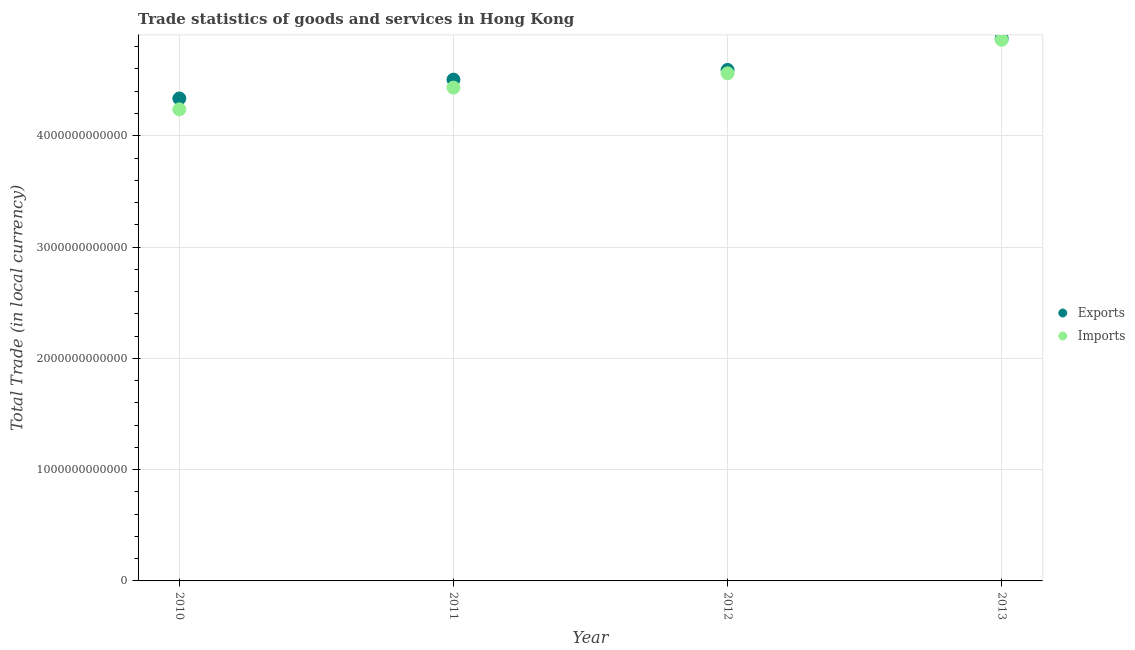Is the number of dotlines equal to the number of legend labels?
Ensure brevity in your answer.  Yes. What is the imports of goods and services in 2010?
Provide a succinct answer. 4.24e+12. Across all years, what is the maximum export of goods and services?
Your answer should be compact. 4.87e+12. Across all years, what is the minimum export of goods and services?
Make the answer very short. 4.34e+12. In which year was the imports of goods and services minimum?
Provide a succinct answer. 2010. What is the total export of goods and services in the graph?
Your response must be concise. 1.83e+13. What is the difference between the export of goods and services in 2012 and that in 2013?
Provide a succinct answer. -2.83e+11. What is the difference between the imports of goods and services in 2011 and the export of goods and services in 2010?
Ensure brevity in your answer.  9.74e+1. What is the average export of goods and services per year?
Your answer should be compact. 4.58e+12. In the year 2010, what is the difference between the export of goods and services and imports of goods and services?
Give a very brief answer. 9.79e+1. What is the ratio of the imports of goods and services in 2011 to that in 2012?
Offer a terse response. 0.97. Is the export of goods and services in 2012 less than that in 2013?
Keep it short and to the point. Yes. What is the difference between the highest and the second highest imports of goods and services?
Make the answer very short. 3.01e+11. What is the difference between the highest and the lowest export of goods and services?
Give a very brief answer. 5.40e+11. In how many years, is the imports of goods and services greater than the average imports of goods and services taken over all years?
Ensure brevity in your answer.  2. Is the sum of the imports of goods and services in 2011 and 2012 greater than the maximum export of goods and services across all years?
Ensure brevity in your answer.  Yes. Does the export of goods and services monotonically increase over the years?
Your response must be concise. Yes. Is the export of goods and services strictly greater than the imports of goods and services over the years?
Ensure brevity in your answer.  Yes. Is the imports of goods and services strictly less than the export of goods and services over the years?
Offer a very short reply. Yes. What is the difference between two consecutive major ticks on the Y-axis?
Give a very brief answer. 1.00e+12. Does the graph contain any zero values?
Your answer should be compact. No. Does the graph contain grids?
Offer a terse response. Yes. How are the legend labels stacked?
Offer a very short reply. Vertical. What is the title of the graph?
Your answer should be compact. Trade statistics of goods and services in Hong Kong. Does "Education" appear as one of the legend labels in the graph?
Your answer should be very brief. No. What is the label or title of the X-axis?
Your answer should be very brief. Year. What is the label or title of the Y-axis?
Offer a terse response. Total Trade (in local currency). What is the Total Trade (in local currency) of Exports in 2010?
Offer a terse response. 4.34e+12. What is the Total Trade (in local currency) in Imports in 2010?
Your answer should be compact. 4.24e+12. What is the Total Trade (in local currency) of Exports in 2011?
Your response must be concise. 4.50e+12. What is the Total Trade (in local currency) in Imports in 2011?
Your answer should be very brief. 4.43e+12. What is the Total Trade (in local currency) of Exports in 2012?
Offer a very short reply. 4.59e+12. What is the Total Trade (in local currency) in Imports in 2012?
Ensure brevity in your answer.  4.56e+12. What is the Total Trade (in local currency) of Exports in 2013?
Keep it short and to the point. 4.87e+12. What is the Total Trade (in local currency) in Imports in 2013?
Your response must be concise. 4.86e+12. Across all years, what is the maximum Total Trade (in local currency) in Exports?
Provide a short and direct response. 4.87e+12. Across all years, what is the maximum Total Trade (in local currency) of Imports?
Ensure brevity in your answer.  4.86e+12. Across all years, what is the minimum Total Trade (in local currency) of Exports?
Keep it short and to the point. 4.34e+12. Across all years, what is the minimum Total Trade (in local currency) in Imports?
Your response must be concise. 4.24e+12. What is the total Total Trade (in local currency) in Exports in the graph?
Offer a very short reply. 1.83e+13. What is the total Total Trade (in local currency) in Imports in the graph?
Give a very brief answer. 1.81e+13. What is the difference between the Total Trade (in local currency) of Exports in 2010 and that in 2011?
Give a very brief answer. -1.69e+11. What is the difference between the Total Trade (in local currency) in Imports in 2010 and that in 2011?
Make the answer very short. -1.95e+11. What is the difference between the Total Trade (in local currency) of Exports in 2010 and that in 2012?
Your response must be concise. -2.57e+11. What is the difference between the Total Trade (in local currency) in Imports in 2010 and that in 2012?
Ensure brevity in your answer.  -3.24e+11. What is the difference between the Total Trade (in local currency) of Exports in 2010 and that in 2013?
Offer a terse response. -5.40e+11. What is the difference between the Total Trade (in local currency) in Imports in 2010 and that in 2013?
Offer a terse response. -6.25e+11. What is the difference between the Total Trade (in local currency) in Exports in 2011 and that in 2012?
Offer a very short reply. -8.76e+1. What is the difference between the Total Trade (in local currency) in Imports in 2011 and that in 2012?
Give a very brief answer. -1.29e+11. What is the difference between the Total Trade (in local currency) in Exports in 2011 and that in 2013?
Provide a short and direct response. -3.71e+11. What is the difference between the Total Trade (in local currency) in Imports in 2011 and that in 2013?
Make the answer very short. -4.30e+11. What is the difference between the Total Trade (in local currency) in Exports in 2012 and that in 2013?
Provide a succinct answer. -2.83e+11. What is the difference between the Total Trade (in local currency) of Imports in 2012 and that in 2013?
Give a very brief answer. -3.01e+11. What is the difference between the Total Trade (in local currency) of Exports in 2010 and the Total Trade (in local currency) of Imports in 2011?
Ensure brevity in your answer.  -9.74e+1. What is the difference between the Total Trade (in local currency) of Exports in 2010 and the Total Trade (in local currency) of Imports in 2012?
Provide a succinct answer. -2.26e+11. What is the difference between the Total Trade (in local currency) of Exports in 2010 and the Total Trade (in local currency) of Imports in 2013?
Offer a terse response. -5.27e+11. What is the difference between the Total Trade (in local currency) of Exports in 2011 and the Total Trade (in local currency) of Imports in 2012?
Provide a short and direct response. -5.70e+1. What is the difference between the Total Trade (in local currency) of Exports in 2011 and the Total Trade (in local currency) of Imports in 2013?
Ensure brevity in your answer.  -3.58e+11. What is the difference between the Total Trade (in local currency) of Exports in 2012 and the Total Trade (in local currency) of Imports in 2013?
Your answer should be compact. -2.70e+11. What is the average Total Trade (in local currency) in Exports per year?
Provide a short and direct response. 4.58e+12. What is the average Total Trade (in local currency) of Imports per year?
Provide a short and direct response. 4.52e+12. In the year 2010, what is the difference between the Total Trade (in local currency) of Exports and Total Trade (in local currency) of Imports?
Give a very brief answer. 9.79e+1. In the year 2011, what is the difference between the Total Trade (in local currency) in Exports and Total Trade (in local currency) in Imports?
Provide a succinct answer. 7.15e+1. In the year 2012, what is the difference between the Total Trade (in local currency) in Exports and Total Trade (in local currency) in Imports?
Ensure brevity in your answer.  3.06e+1. In the year 2013, what is the difference between the Total Trade (in local currency) in Exports and Total Trade (in local currency) in Imports?
Make the answer very short. 1.25e+1. What is the ratio of the Total Trade (in local currency) of Exports in 2010 to that in 2011?
Ensure brevity in your answer.  0.96. What is the ratio of the Total Trade (in local currency) in Imports in 2010 to that in 2011?
Offer a terse response. 0.96. What is the ratio of the Total Trade (in local currency) of Exports in 2010 to that in 2012?
Your answer should be compact. 0.94. What is the ratio of the Total Trade (in local currency) in Imports in 2010 to that in 2012?
Provide a short and direct response. 0.93. What is the ratio of the Total Trade (in local currency) in Exports in 2010 to that in 2013?
Keep it short and to the point. 0.89. What is the ratio of the Total Trade (in local currency) of Imports in 2010 to that in 2013?
Your answer should be compact. 0.87. What is the ratio of the Total Trade (in local currency) of Exports in 2011 to that in 2012?
Offer a very short reply. 0.98. What is the ratio of the Total Trade (in local currency) of Imports in 2011 to that in 2012?
Ensure brevity in your answer.  0.97. What is the ratio of the Total Trade (in local currency) in Exports in 2011 to that in 2013?
Offer a very short reply. 0.92. What is the ratio of the Total Trade (in local currency) of Imports in 2011 to that in 2013?
Offer a terse response. 0.91. What is the ratio of the Total Trade (in local currency) of Exports in 2012 to that in 2013?
Offer a very short reply. 0.94. What is the ratio of the Total Trade (in local currency) in Imports in 2012 to that in 2013?
Offer a terse response. 0.94. What is the difference between the highest and the second highest Total Trade (in local currency) of Exports?
Provide a succinct answer. 2.83e+11. What is the difference between the highest and the second highest Total Trade (in local currency) of Imports?
Provide a succinct answer. 3.01e+11. What is the difference between the highest and the lowest Total Trade (in local currency) in Exports?
Provide a short and direct response. 5.40e+11. What is the difference between the highest and the lowest Total Trade (in local currency) in Imports?
Ensure brevity in your answer.  6.25e+11. 